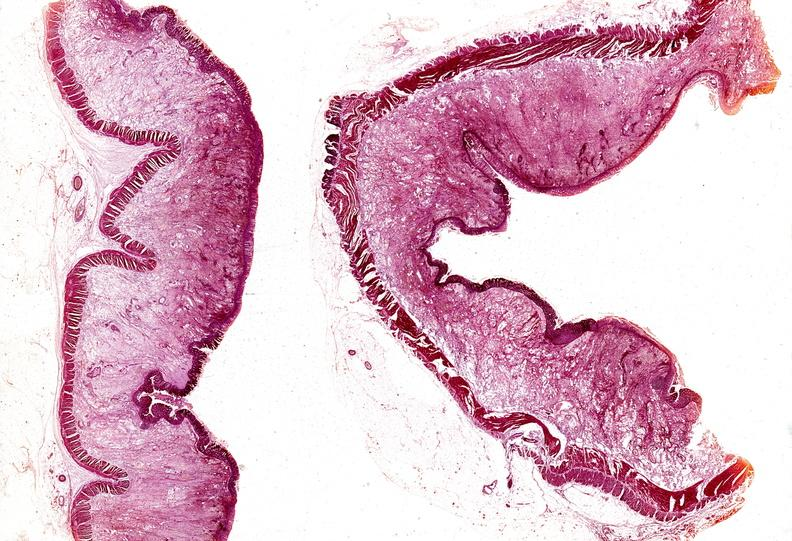s gastrointestinal present?
Answer the question using a single word or phrase. Yes 